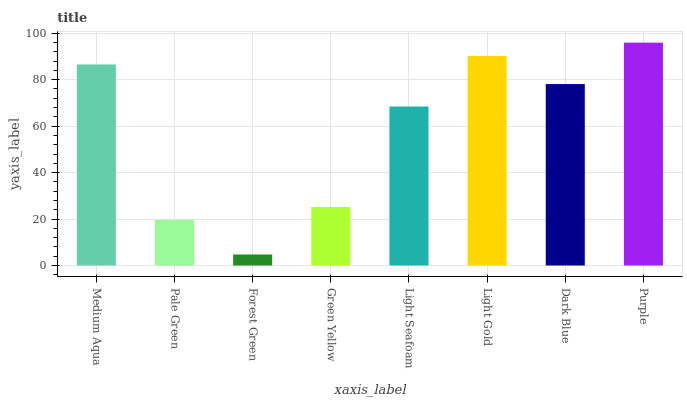Is Forest Green the minimum?
Answer yes or no. Yes. Is Purple the maximum?
Answer yes or no. Yes. Is Pale Green the minimum?
Answer yes or no. No. Is Pale Green the maximum?
Answer yes or no. No. Is Medium Aqua greater than Pale Green?
Answer yes or no. Yes. Is Pale Green less than Medium Aqua?
Answer yes or no. Yes. Is Pale Green greater than Medium Aqua?
Answer yes or no. No. Is Medium Aqua less than Pale Green?
Answer yes or no. No. Is Dark Blue the high median?
Answer yes or no. Yes. Is Light Seafoam the low median?
Answer yes or no. Yes. Is Medium Aqua the high median?
Answer yes or no. No. Is Light Gold the low median?
Answer yes or no. No. 